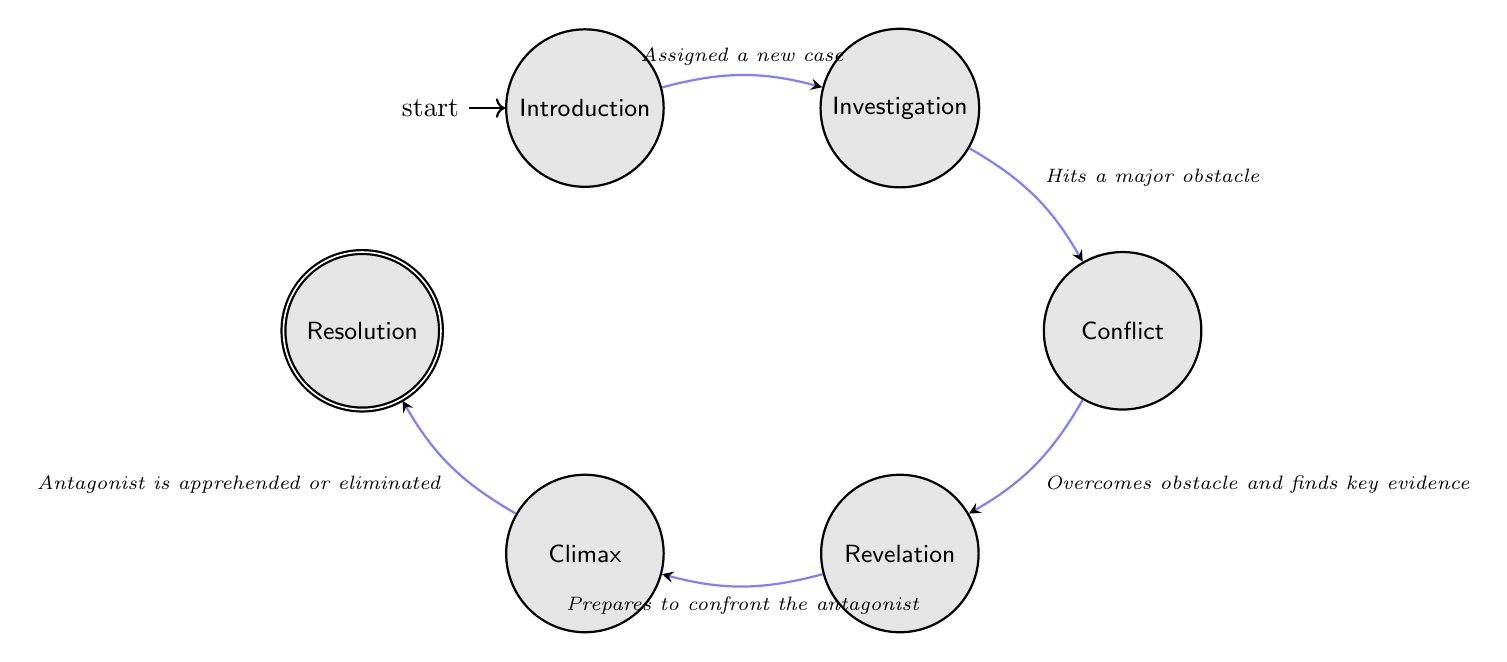What is the total number of states in the diagram? The diagram contains a total of 6 nodes: Introduction, Investigation, Conflict, Revelation, Climax, and Resolution.
Answer: 6 What state comes directly after Investigation? The state that follows Investigation in the diagram is Conflict.
Answer: Conflict What trigger leads from the Conflict state to the Revelation state? The transition from Conflict to Revelation is triggered by overcoming an obstacle and finding key evidence.
Answer: Overcomes obstacle and finds key evidence How many transitions are there in total? The diagram has 5 transitions connecting the different states with specific triggers.
Answer: 5 What is the initial state of the machine? The initial state of the finite state machine is Introduction, which is where the story begins.
Answer: Introduction What state does the protagonist reach after preparing to confront the antagonist? After preparing to confront the antagonist, the protagonist reaches the Climax state in the story.
Answer: Climax What is the last state the protagonist encounters in this storyline? The last state in this storyline, after apprehending or eliminating the antagonist, is Resolution.
Answer: Resolution What are the primary obstacles faced in the Conflict state? In the Conflict state, the protagonist faces personal and professional challenges, which may include threats or accusations.
Answer: Personal and professional challenges What is the connection between the Revelation state and the Climax state? The connection is that the protagonist prepares to confront the antagonist after uncovering critical information in the Revelation state.
Answer: Prepares to confront the antagonist 